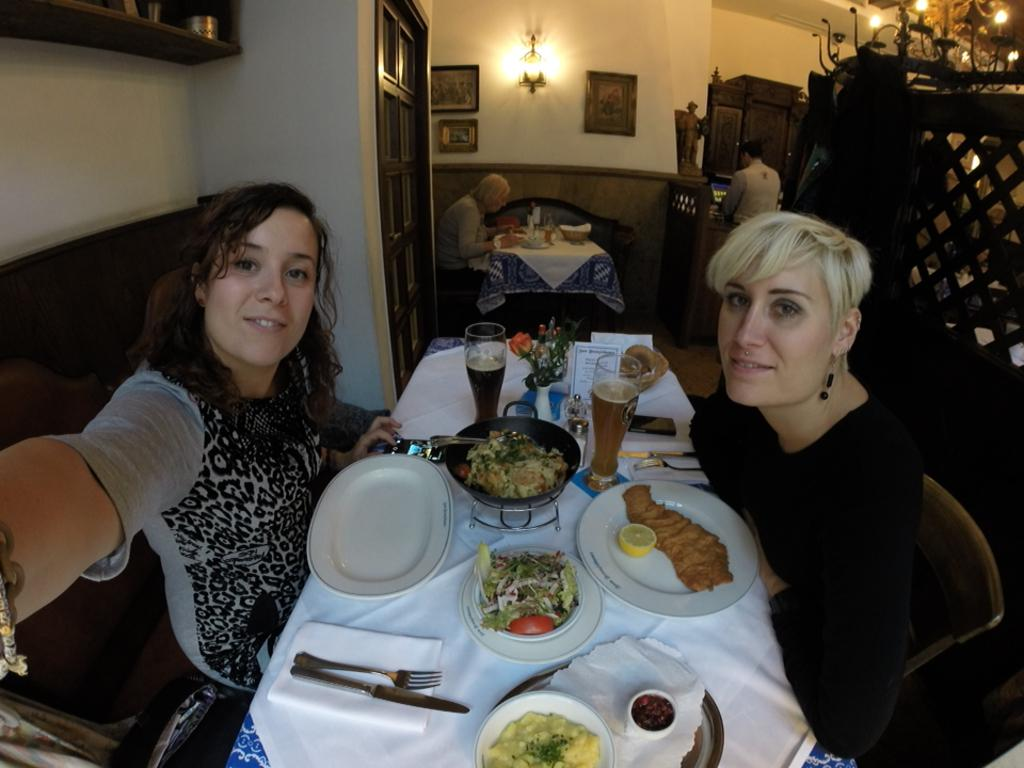How many women are sitting in the front of the image? There are two women sitting in front in the image. Can you describe the seating arrangement of the women? There is a woman sitting behind the two women sitting in front. What is visible at the top of the image? There is a light visible at the top of the image. Where is the hose located in the image? There is no hose present in the image. What type of shelf can be seen in the background? There is no shelf visible in the image. 